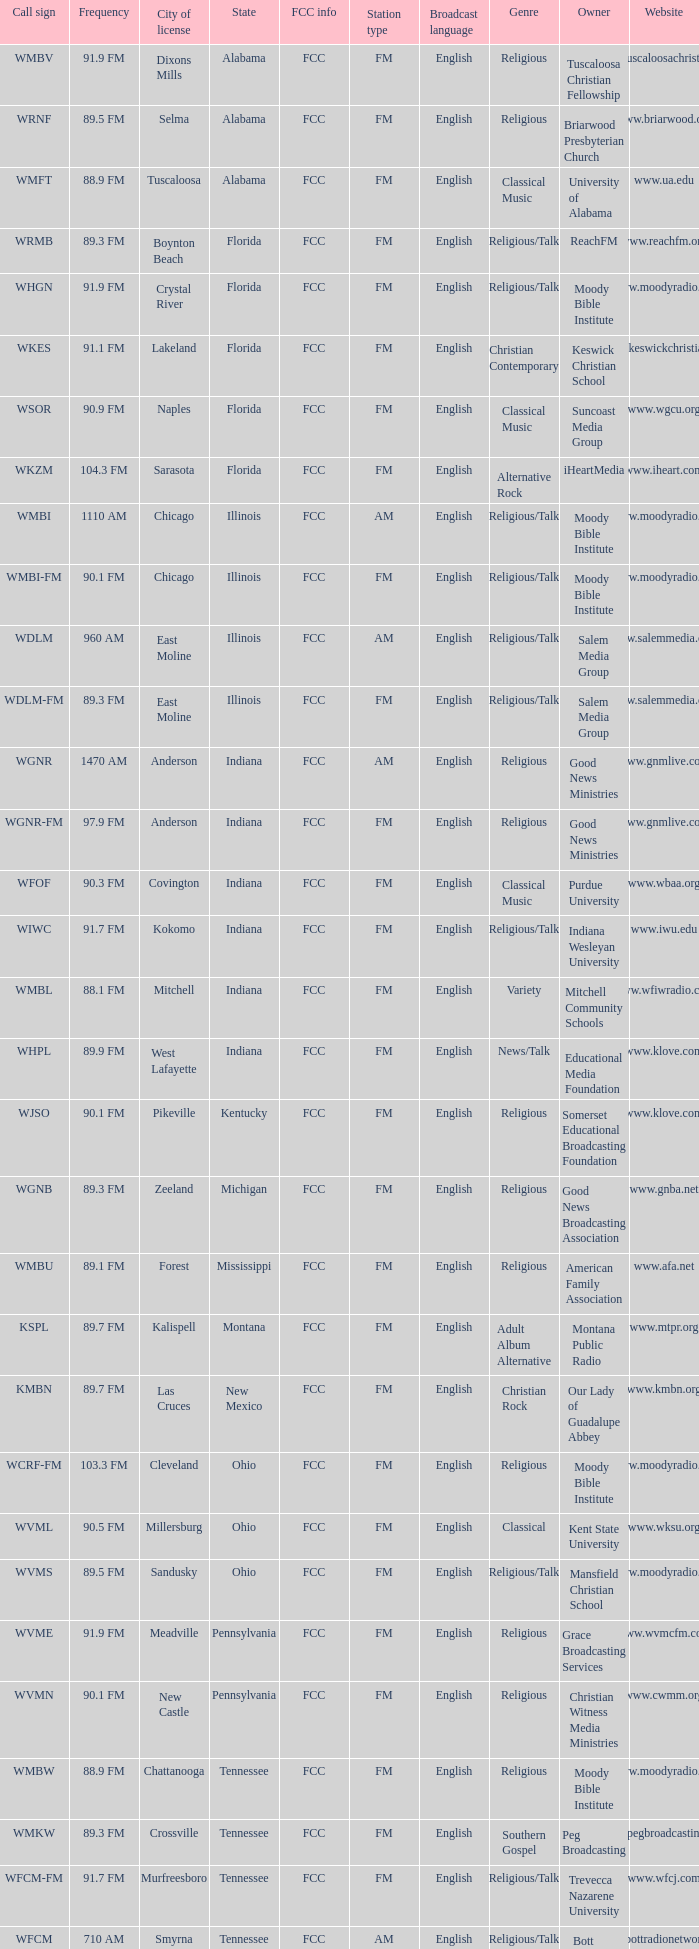What is the FCC info for the radio station in West Lafayette, Indiana? FCC. 